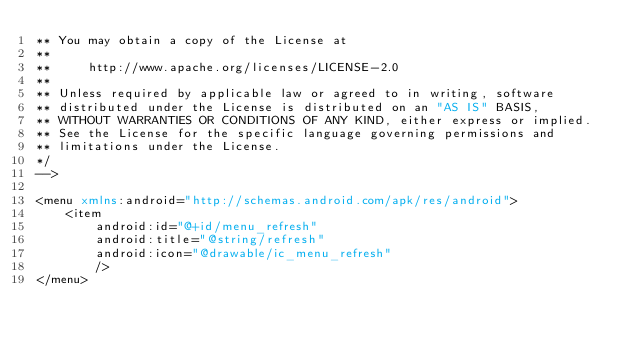Convert code to text. <code><loc_0><loc_0><loc_500><loc_500><_XML_>** You may obtain a copy of the License at 
**
**     http://www.apache.org/licenses/LICENSE-2.0 
**
** Unless required by applicable law or agreed to in writing, software 
** distributed under the License is distributed on an "AS IS" BASIS, 
** WITHOUT WARRANTIES OR CONDITIONS OF ANY KIND, either express or implied. 
** See the License for the specific language governing permissions and 
** limitations under the License.
*/
-->

<menu xmlns:android="http://schemas.android.com/apk/res/android">
	<item
		android:id="@+id/menu_refresh"
		android:title="@string/refresh"
		android:icon="@drawable/ic_menu_refresh"
		/>
</menu>
</code> 